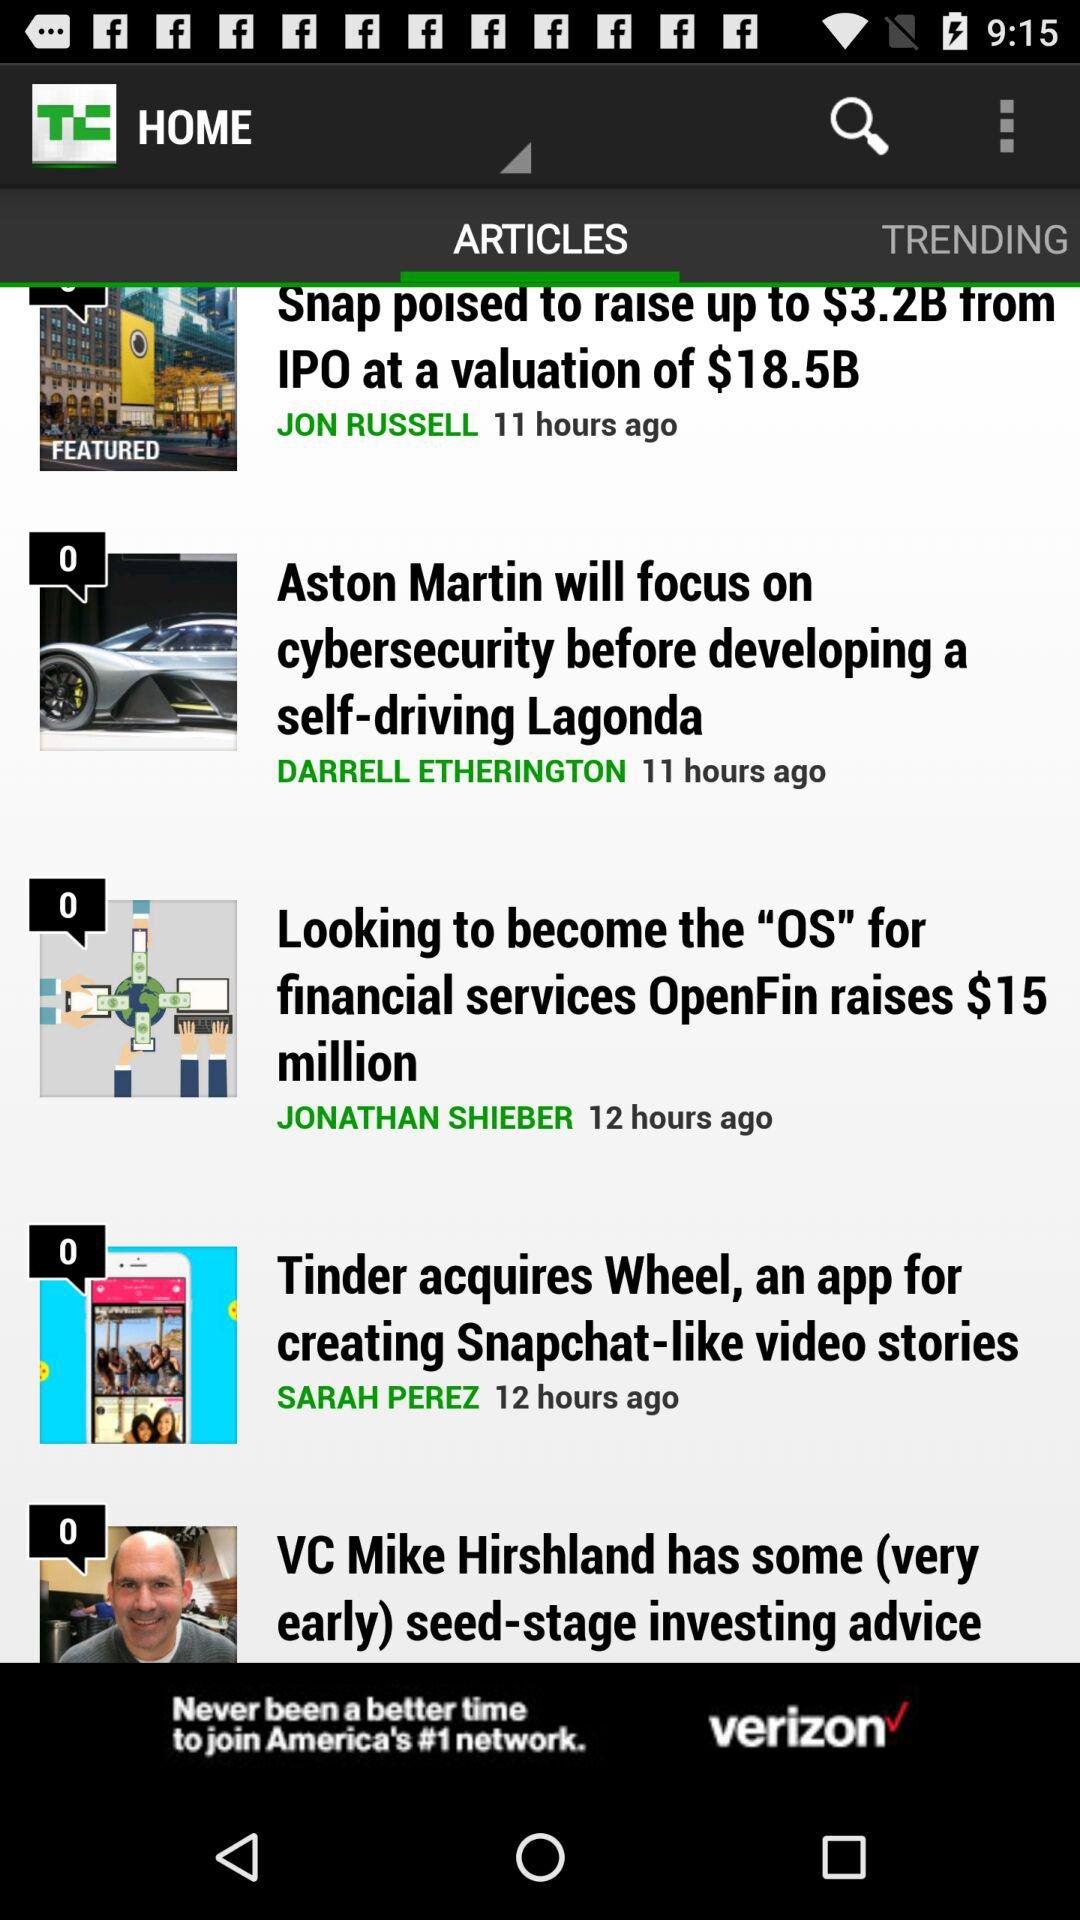What is the publication time of the article "Tinder acquires Wheel, an app for creating Snapchat-like video stories"? The publication time of the article "Tinder acquires Wheel, an app for creating Snapchat-like video stories" is of 12 hours ago. 